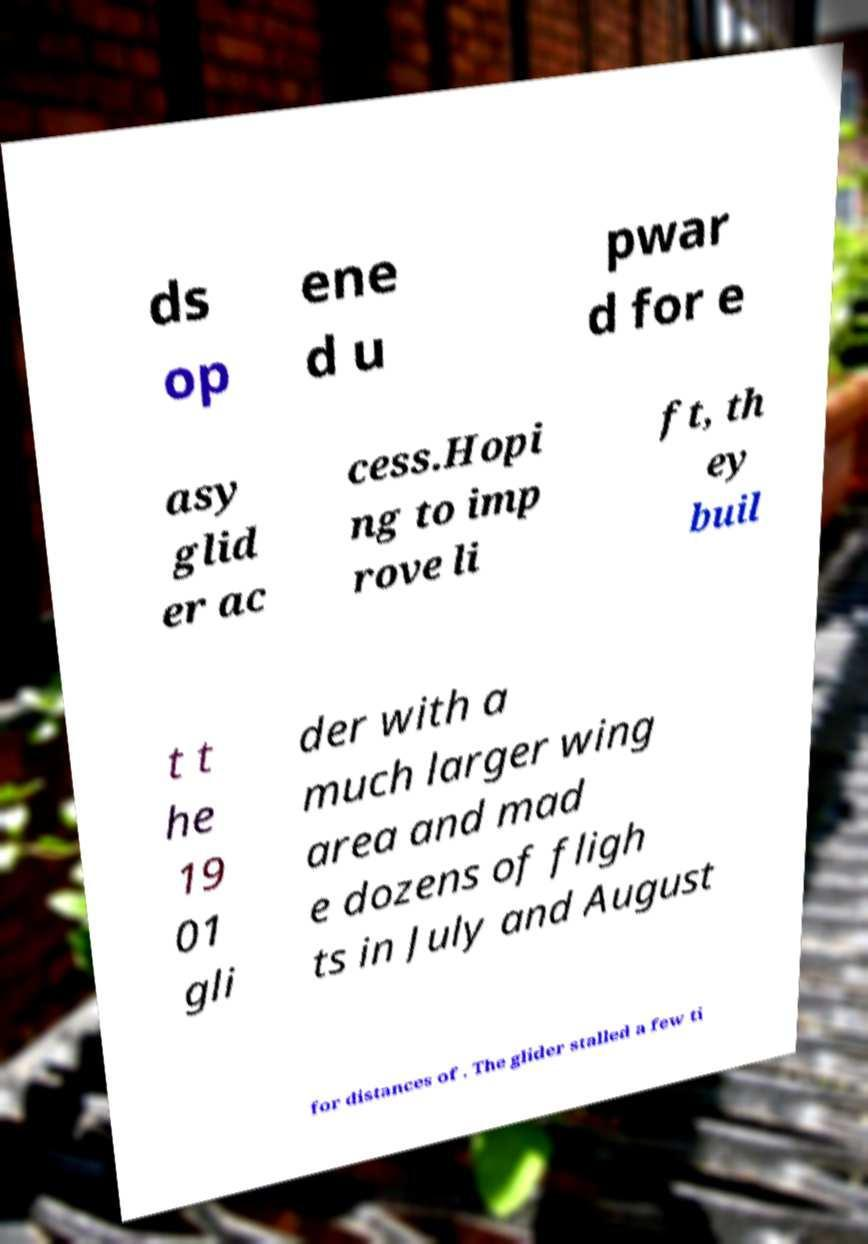Please identify and transcribe the text found in this image. ds op ene d u pwar d for e asy glid er ac cess.Hopi ng to imp rove li ft, th ey buil t t he 19 01 gli der with a much larger wing area and mad e dozens of fligh ts in July and August for distances of . The glider stalled a few ti 